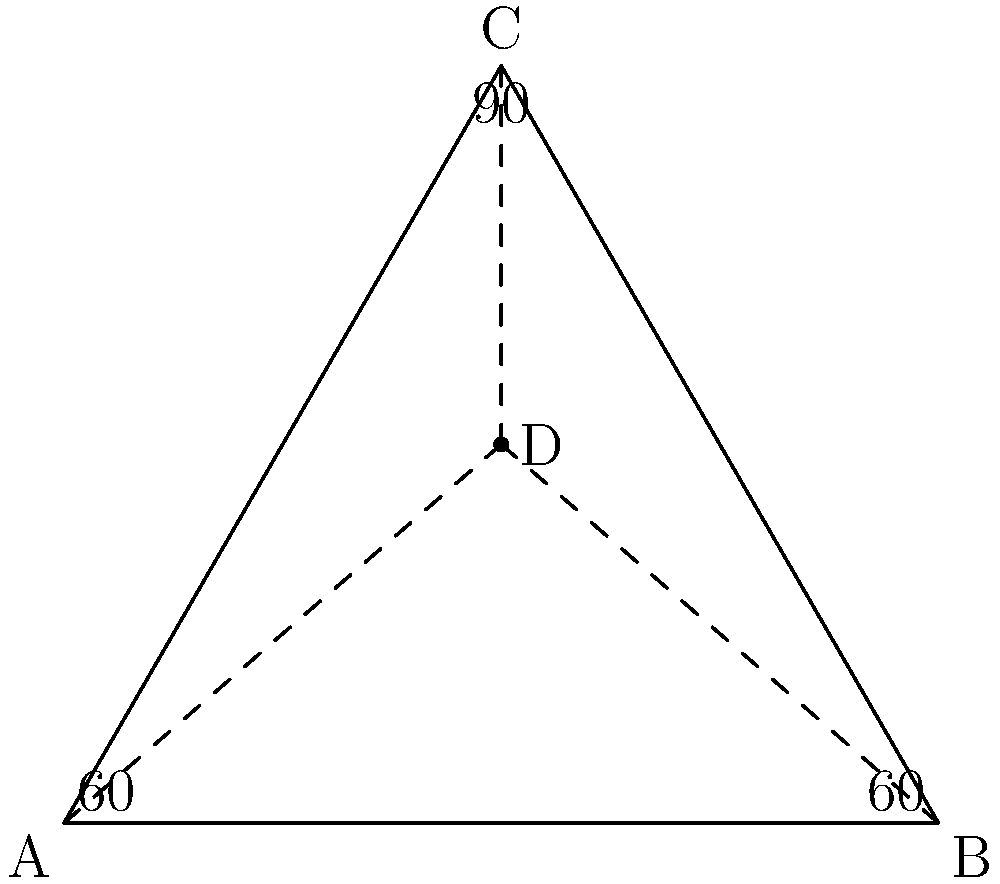In a non-Euclidean soccer field layout, we have a triangular section ABC where angles A and B are both 60°, and angle C is 90°. Point D is the center of this triangular section. If the sum of the angles in triangle ACD is 210°, what is the measure of angle ACD? Let's approach this step-by-step:

1) In Euclidean geometry, the sum of angles in a triangle is always 180°. However, we're dealing with non-Euclidean geometry here.

2) We're given that the sum of angles in triangle ACD is 210°. This is 30° more than in Euclidean geometry, indicating we're working on a positively curved surface (like a sphere).

3) In the original triangle ABC:
   - Angle A = 60°
   - Angle B = 60°
   - Angle C = 90°
   Sum = 210°

4) This matches the sum we're given for triangle ACD, suggesting a consistent curvature across the field.

5) Point D is the center of the triangular section, implying it's equidistant from A, B, and C. This means AD = BD = CD.

6) Due to this symmetry, triangles ACD and BCD are congruent.

7) Let's denote angle ACD as x. Due to the symmetry, angle BCD is also x.

8) We know that angle ACB is 90°, so:
   $x + x + 90° = 210°$
   $2x + 90° = 210°$
   $2x = 120°$
   $x = 60°$

Therefore, angle ACD measures 60°.
Answer: 60° 